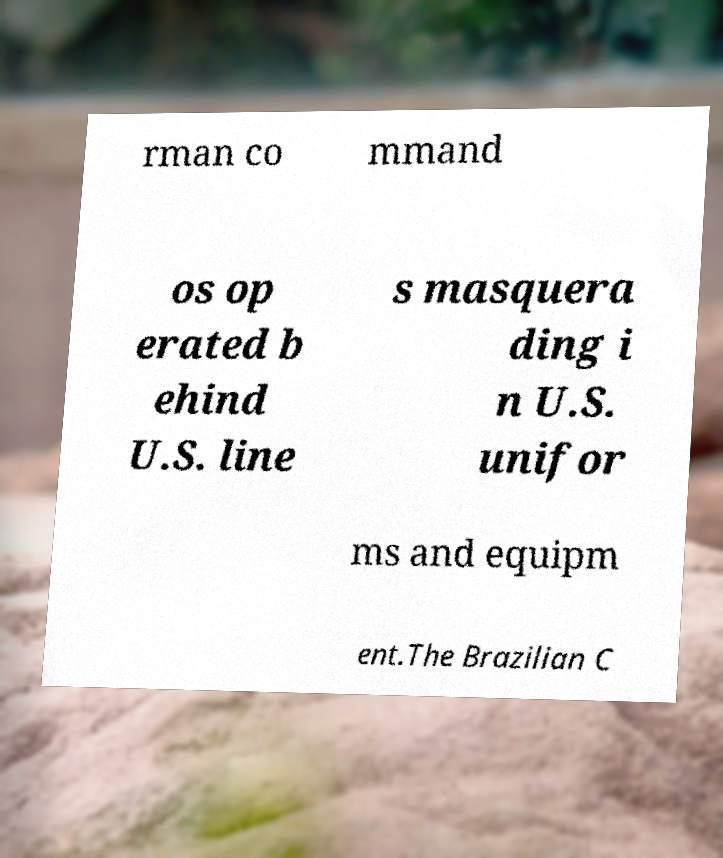For documentation purposes, I need the text within this image transcribed. Could you provide that? rman co mmand os op erated b ehind U.S. line s masquera ding i n U.S. unifor ms and equipm ent.The Brazilian C 